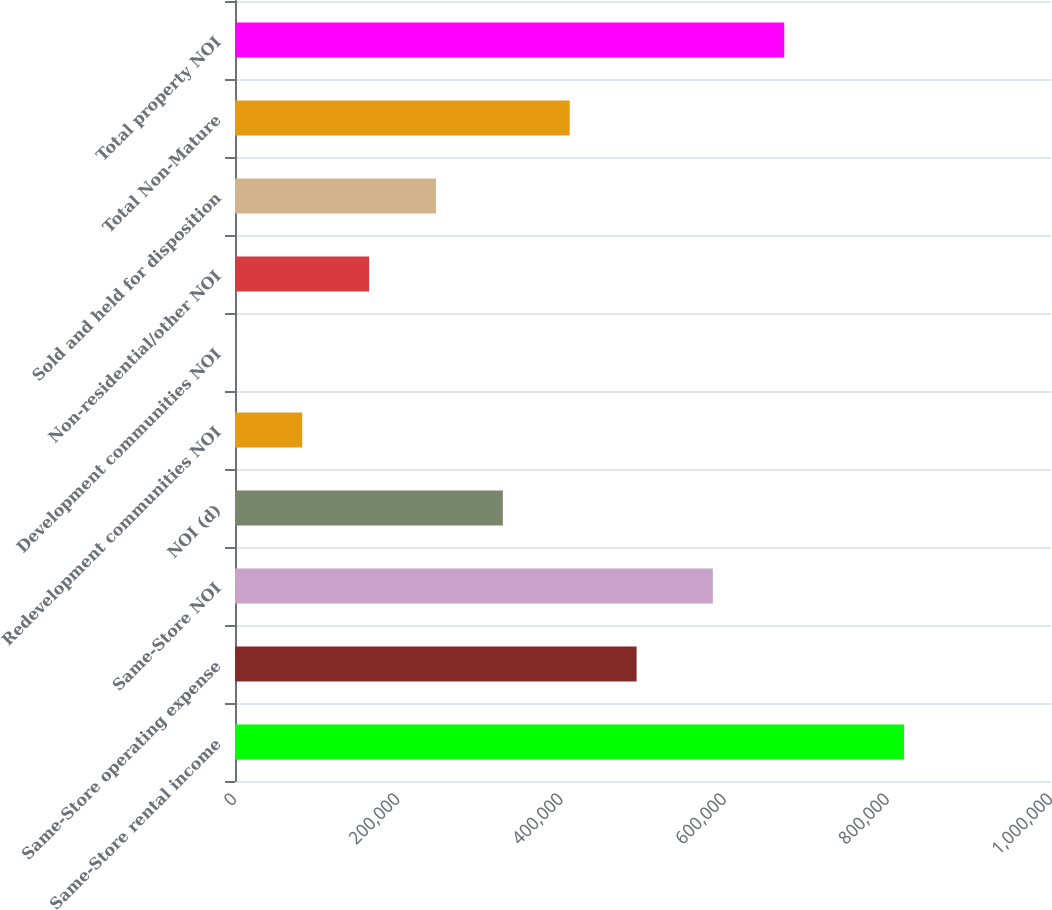Convert chart. <chart><loc_0><loc_0><loc_500><loc_500><bar_chart><fcel>Same-Store rental income<fcel>Same-Store operating expense<fcel>Same-Store NOI<fcel>NOI (d)<fcel>Redevelopment communities NOI<fcel>Development communities NOI<fcel>Non-residential/other NOI<fcel>Sold and held for disposition<fcel>Total Non-Mature<fcel>Total property NOI<nl><fcel>819962<fcel>492152<fcel>585577<fcel>328246<fcel>82388.6<fcel>436<fcel>164341<fcel>246294<fcel>410199<fcel>673085<nl></chart> 